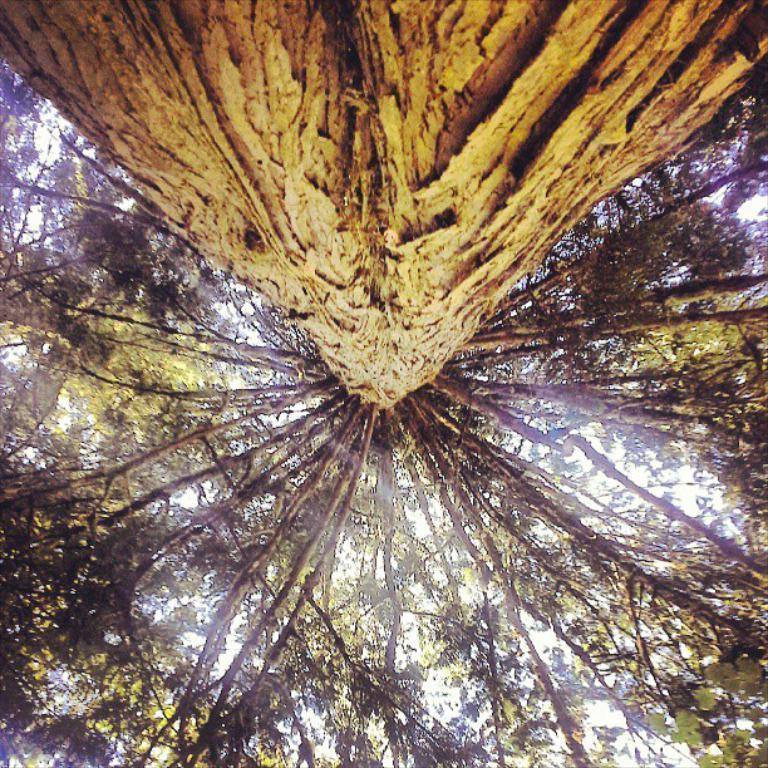How would you summarize this image in a sentence or two? In the image we can see there are lot of trees and in front there is a stem of the tree. 